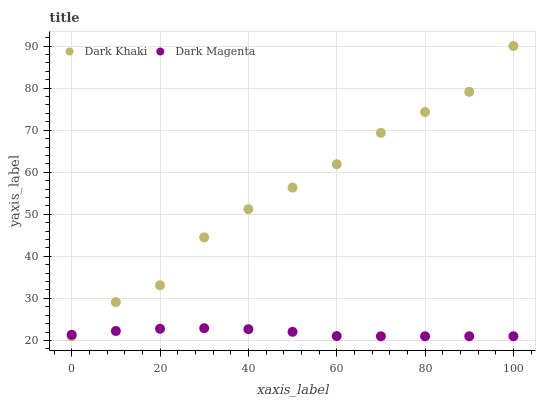Does Dark Magenta have the minimum area under the curve?
Answer yes or no. Yes. Does Dark Khaki have the maximum area under the curve?
Answer yes or no. Yes. Does Dark Magenta have the maximum area under the curve?
Answer yes or no. No. Is Dark Magenta the smoothest?
Answer yes or no. Yes. Is Dark Khaki the roughest?
Answer yes or no. Yes. Is Dark Magenta the roughest?
Answer yes or no. No. Does Dark Khaki have the lowest value?
Answer yes or no. Yes. Does Dark Khaki have the highest value?
Answer yes or no. Yes. Does Dark Magenta have the highest value?
Answer yes or no. No. Does Dark Magenta intersect Dark Khaki?
Answer yes or no. Yes. Is Dark Magenta less than Dark Khaki?
Answer yes or no. No. Is Dark Magenta greater than Dark Khaki?
Answer yes or no. No. 